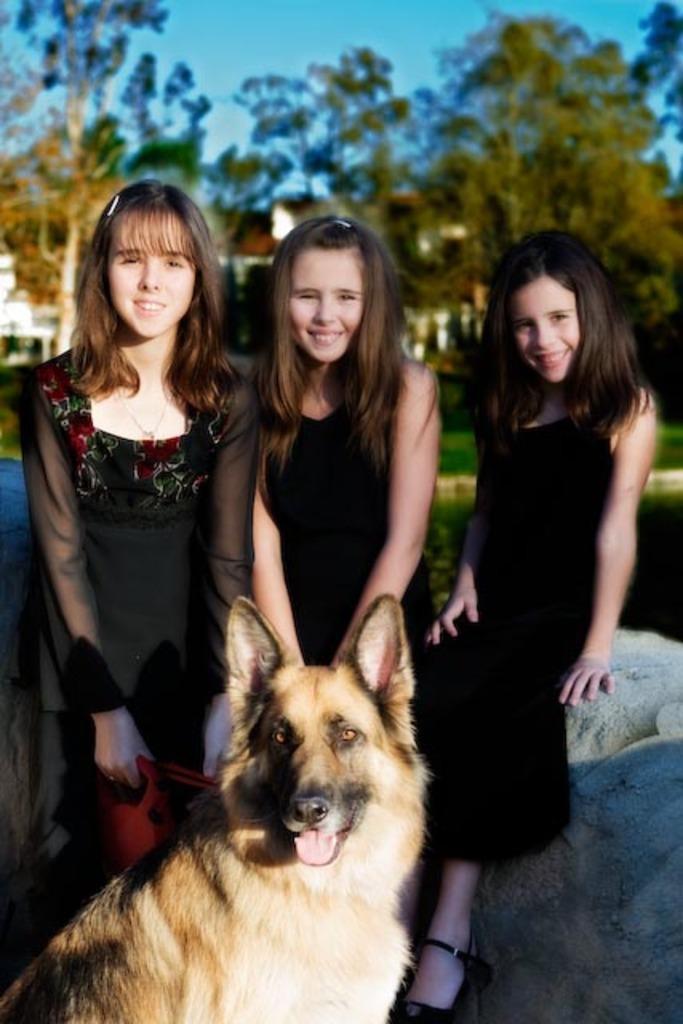Please provide a concise description of this image. In the image we can see there are three girls who are standing and in front of them there is a dog. 